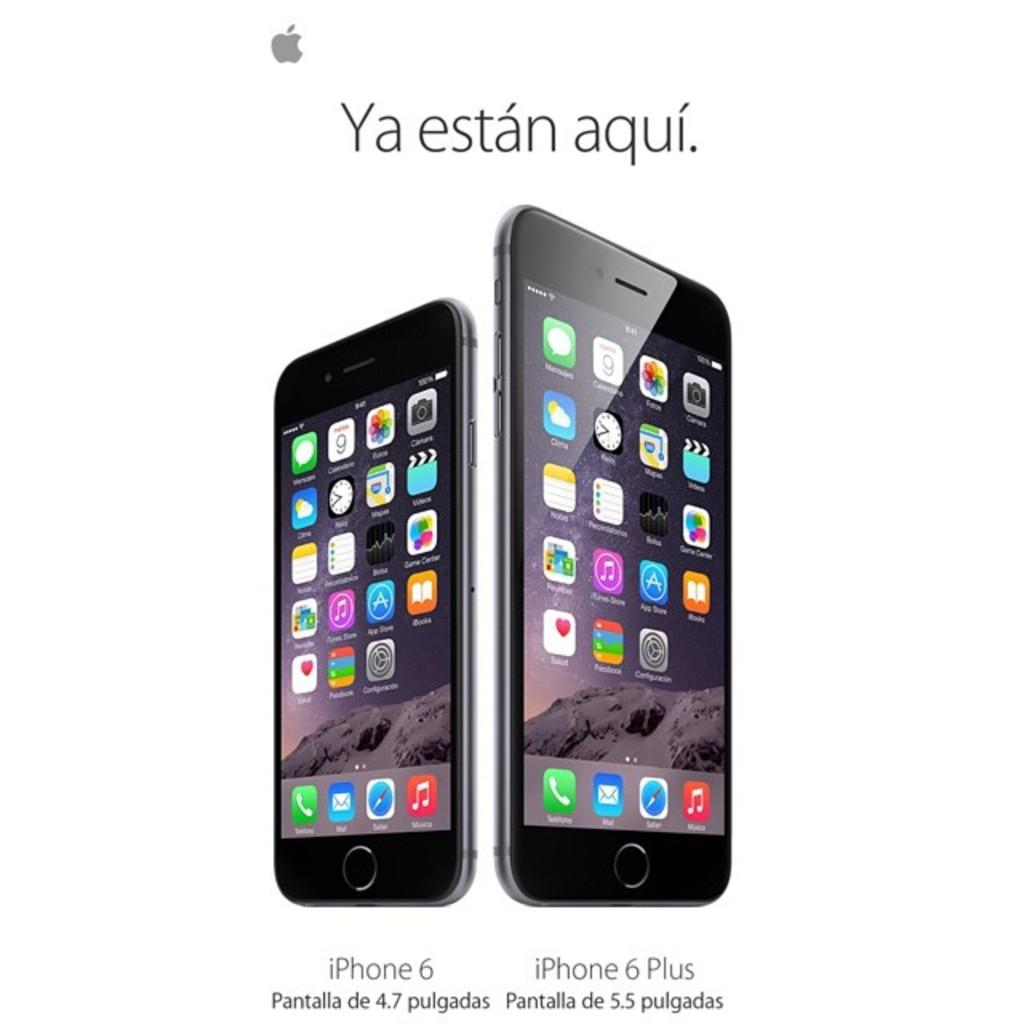<image>
Offer a succinct explanation of the picture presented. The iPhone 6 Plus on the right looks taller than the one  on the left. 